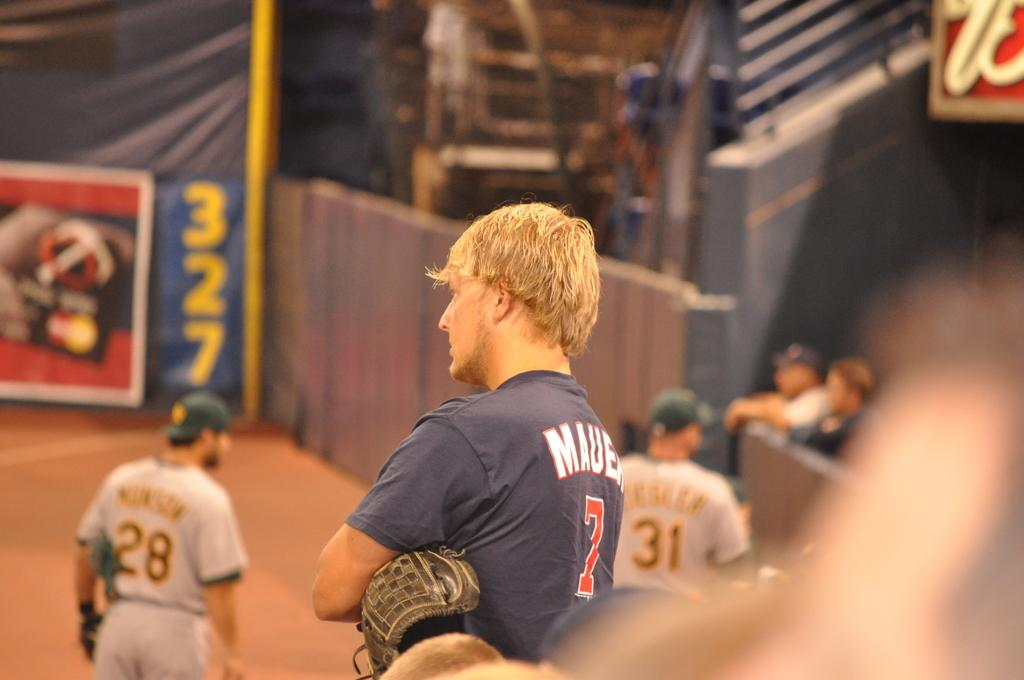<image>
Create a compact narrative representing the image presented. A baseball player wearing a shirt with the number 7 on it. 